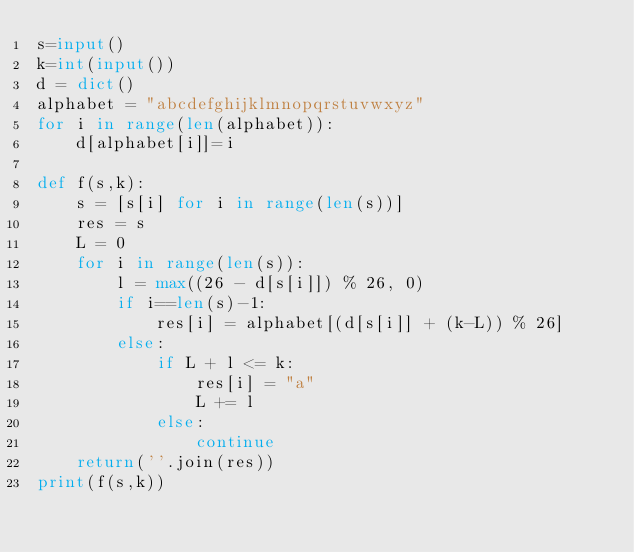Convert code to text. <code><loc_0><loc_0><loc_500><loc_500><_Python_>s=input()
k=int(input())
d = dict()
alphabet = "abcdefghijklmnopqrstuvwxyz"
for i in range(len(alphabet)):
    d[alphabet[i]]=i
    
def f(s,k):
    s = [s[i] for i in range(len(s))]
    res = s
    L = 0
    for i in range(len(s)):
        l = max((26 - d[s[i]]) % 26, 0)
        if i==len(s)-1:
            res[i] = alphabet[(d[s[i]] + (k-L)) % 26]
        else:
            if L + l <= k:
                res[i] = "a"
                L += l
            else:
                continue
    return(''.join(res))
print(f(s,k))</code> 